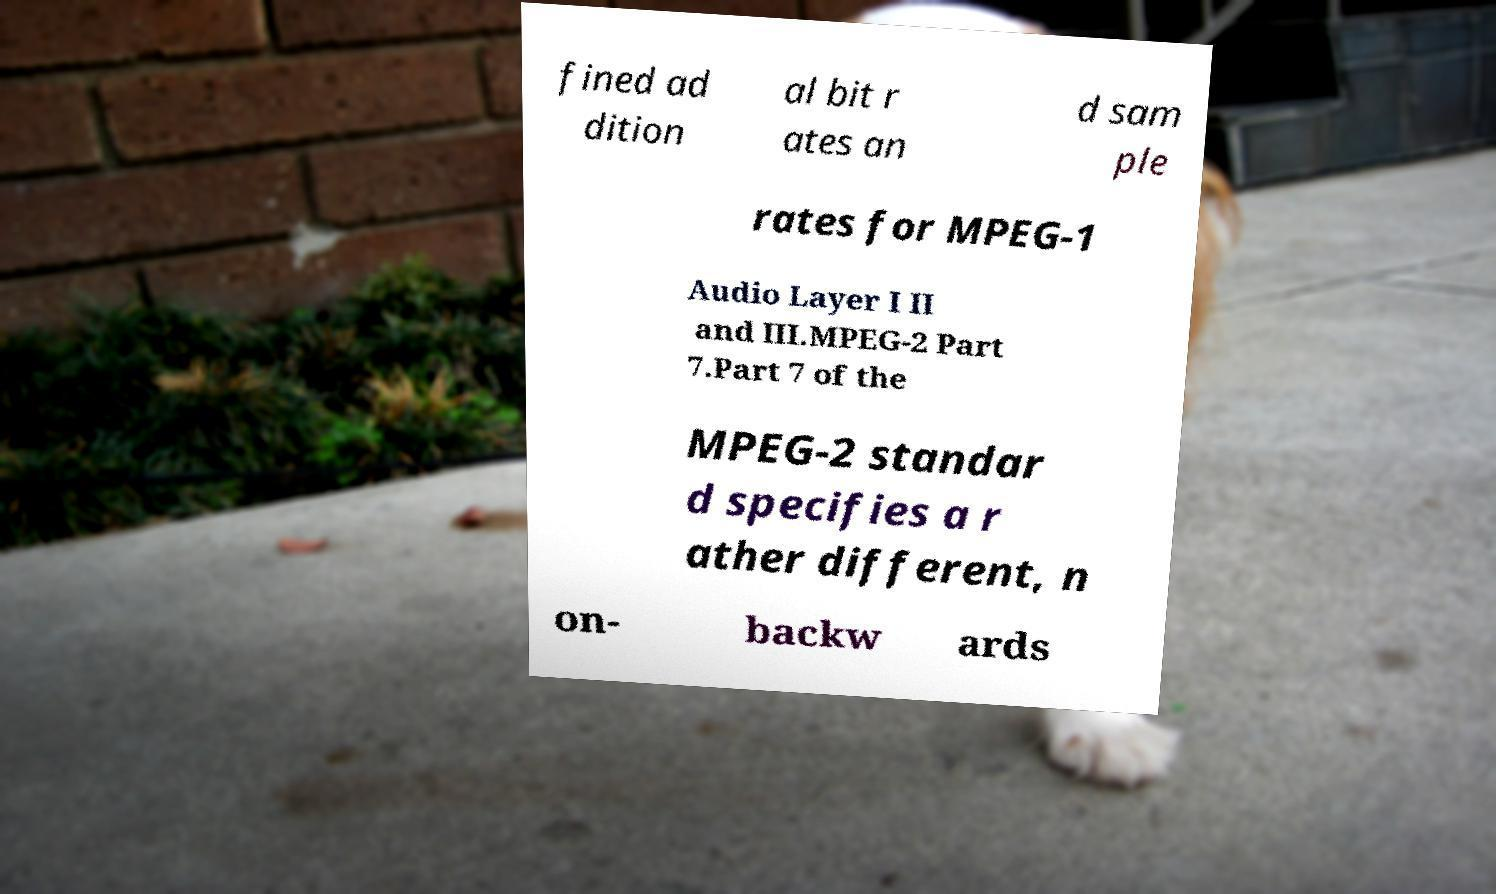Can you read and provide the text displayed in the image?This photo seems to have some interesting text. Can you extract and type it out for me? fined ad dition al bit r ates an d sam ple rates for MPEG-1 Audio Layer I II and III.MPEG-2 Part 7.Part 7 of the MPEG-2 standar d specifies a r ather different, n on- backw ards 